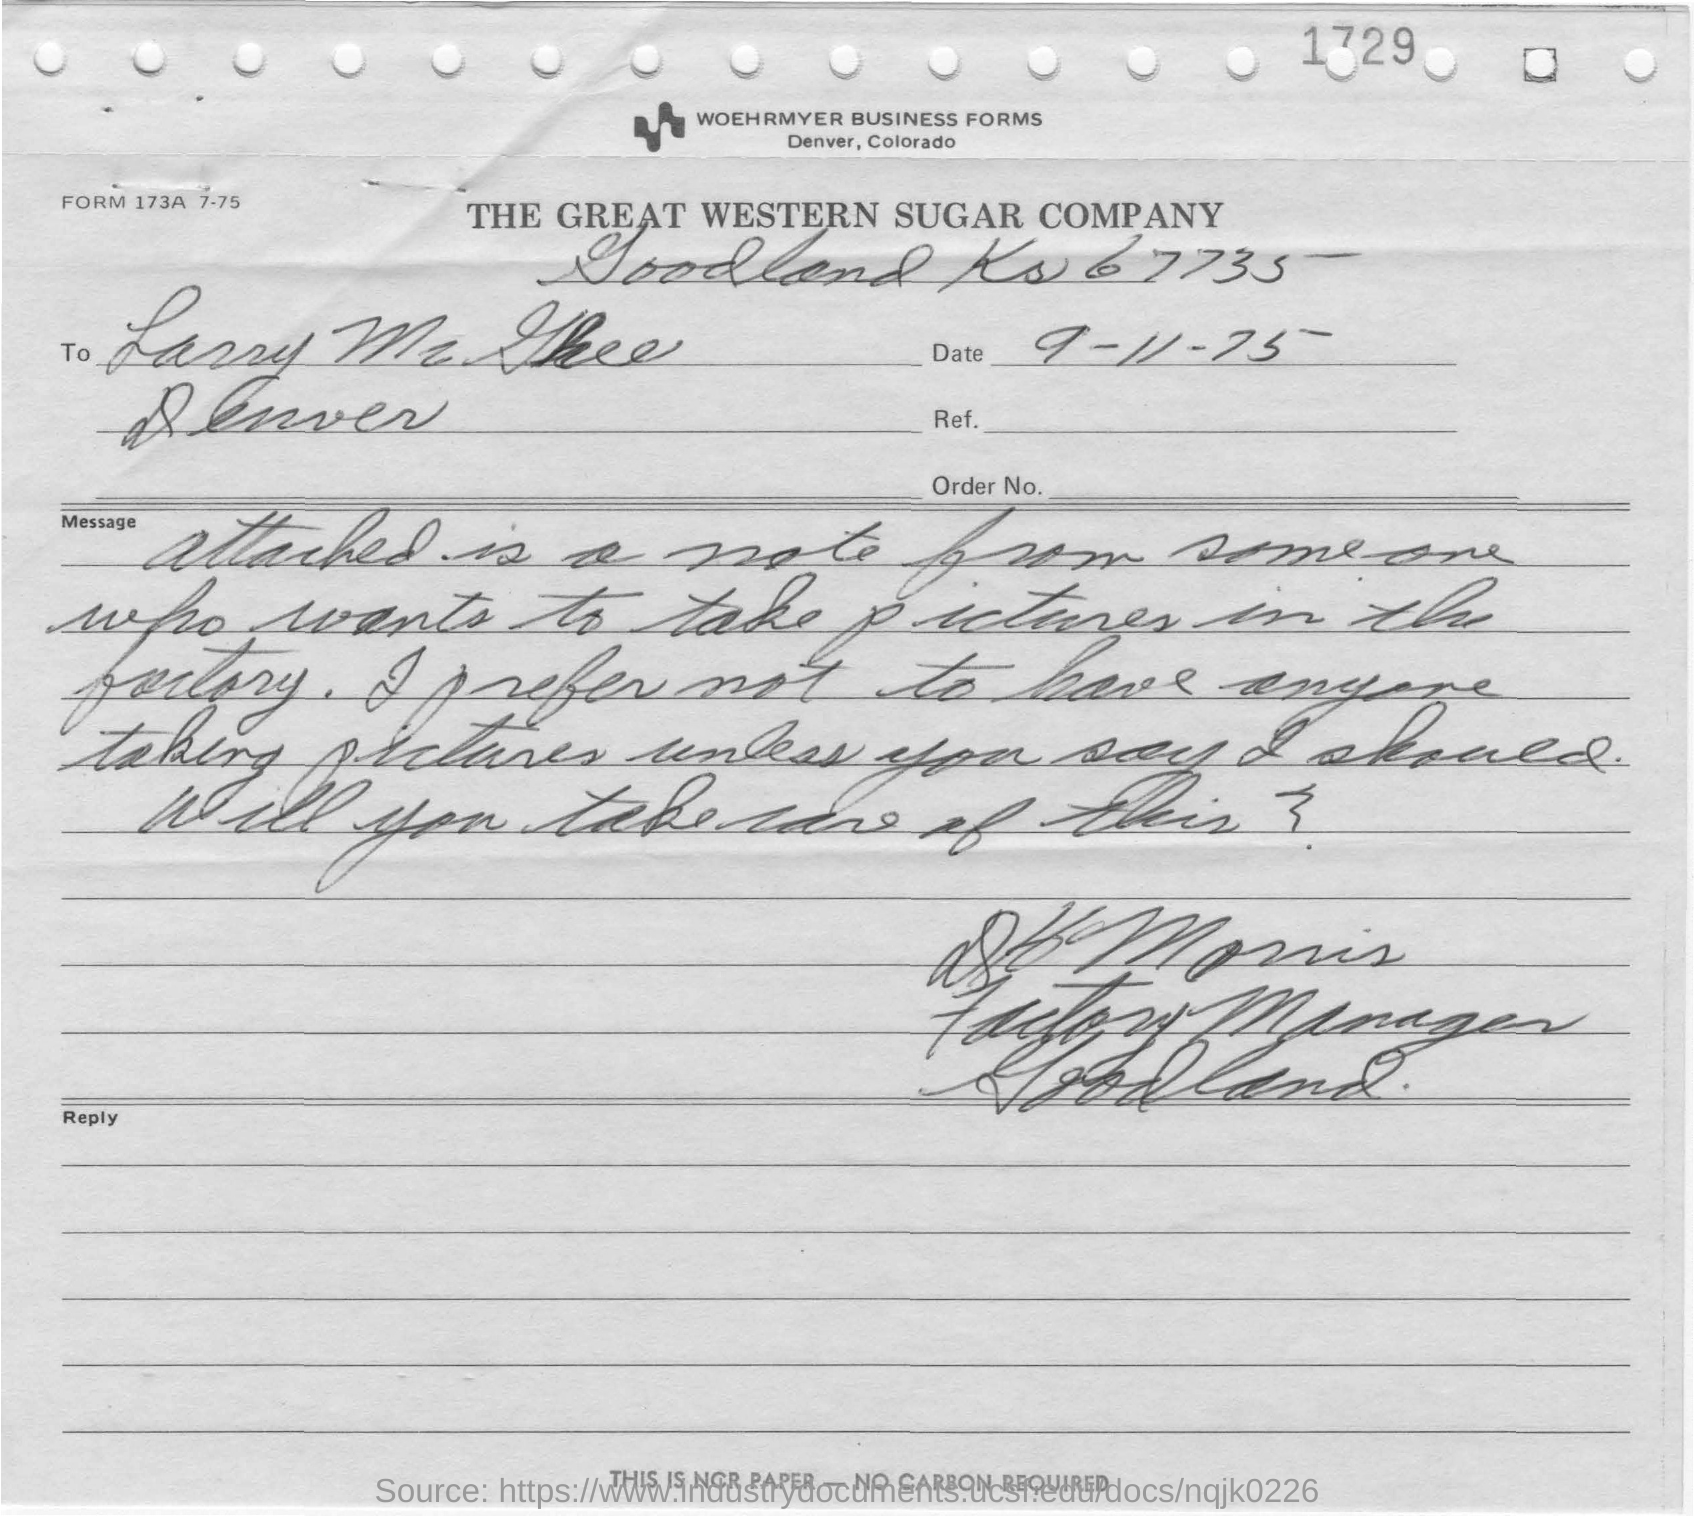Give some essential details in this illustration. The date mentioned in the form is 9-11-75. 